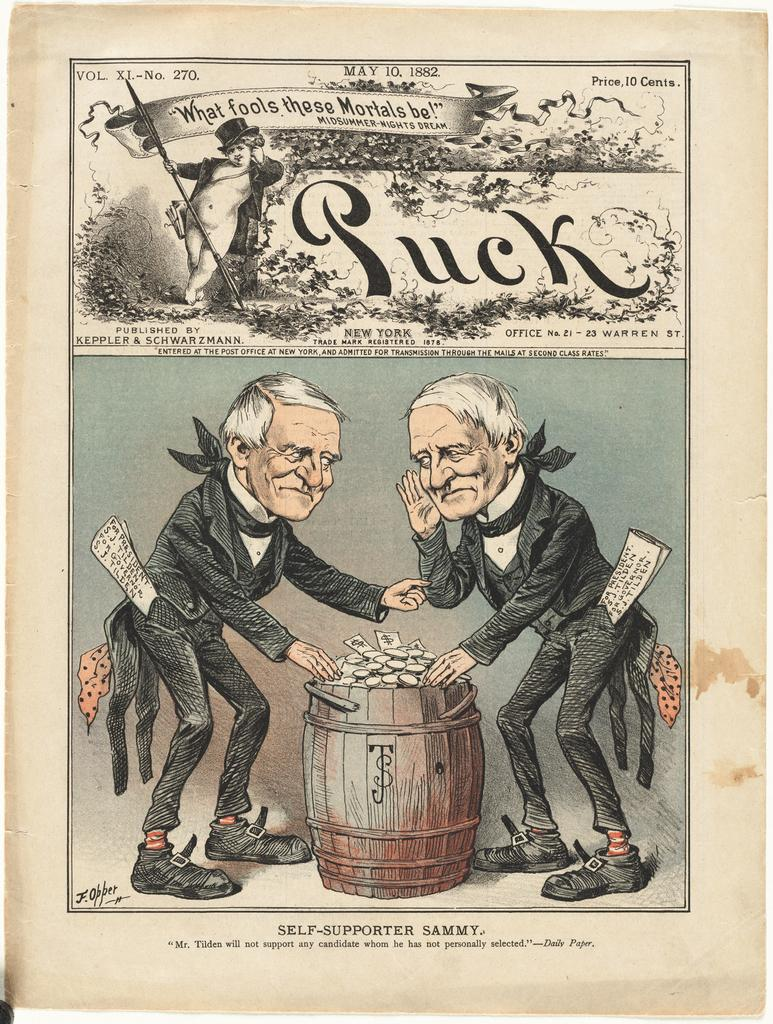Provide a one-sentence caption for the provided image. The old page from Puck magazine shows two old men hunched over a barrel of money. 